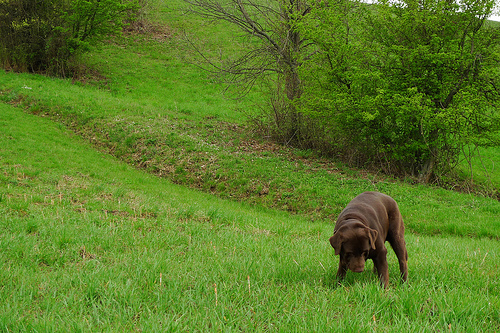<image>
Is the grass land above the dog? No. The grass land is not positioned above the dog. The vertical arrangement shows a different relationship. 